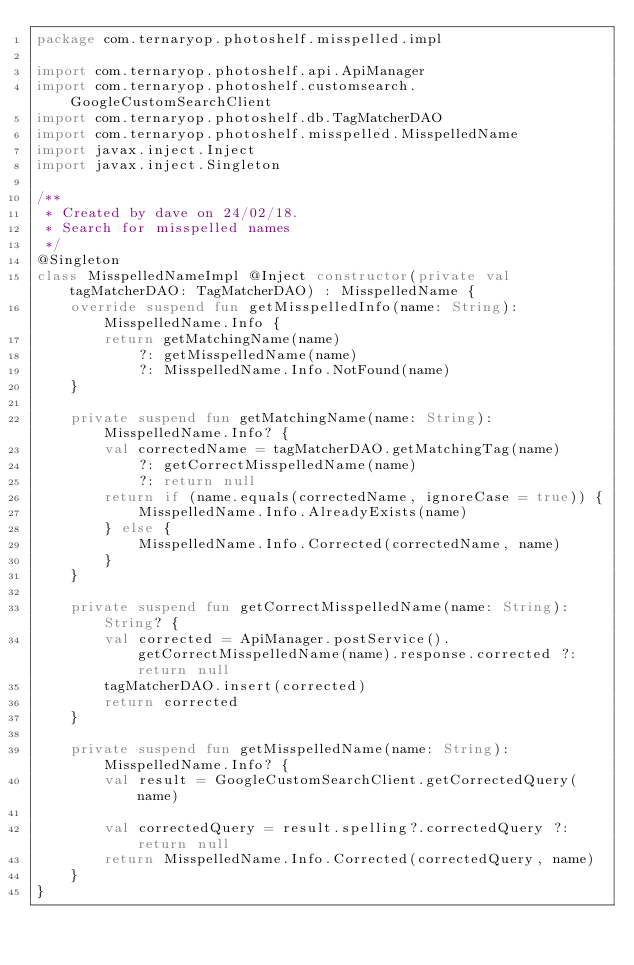Convert code to text. <code><loc_0><loc_0><loc_500><loc_500><_Kotlin_>package com.ternaryop.photoshelf.misspelled.impl

import com.ternaryop.photoshelf.api.ApiManager
import com.ternaryop.photoshelf.customsearch.GoogleCustomSearchClient
import com.ternaryop.photoshelf.db.TagMatcherDAO
import com.ternaryop.photoshelf.misspelled.MisspelledName
import javax.inject.Inject
import javax.inject.Singleton

/**
 * Created by dave on 24/02/18.
 * Search for misspelled names
 */
@Singleton
class MisspelledNameImpl @Inject constructor(private val tagMatcherDAO: TagMatcherDAO) : MisspelledName {
    override suspend fun getMisspelledInfo(name: String): MisspelledName.Info {
        return getMatchingName(name)
            ?: getMisspelledName(name)
            ?: MisspelledName.Info.NotFound(name)
    }

    private suspend fun getMatchingName(name: String): MisspelledName.Info? {
        val correctedName = tagMatcherDAO.getMatchingTag(name)
            ?: getCorrectMisspelledName(name)
            ?: return null
        return if (name.equals(correctedName, ignoreCase = true)) {
            MisspelledName.Info.AlreadyExists(name)
        } else {
            MisspelledName.Info.Corrected(correctedName, name)
        }
    }

    private suspend fun getCorrectMisspelledName(name: String): String? {
        val corrected = ApiManager.postService().getCorrectMisspelledName(name).response.corrected ?: return null
        tagMatcherDAO.insert(corrected)
        return corrected
    }

    private suspend fun getMisspelledName(name: String): MisspelledName.Info? {
        val result = GoogleCustomSearchClient.getCorrectedQuery(name)

        val correctedQuery = result.spelling?.correctedQuery ?: return null
        return MisspelledName.Info.Corrected(correctedQuery, name)
    }
}
</code> 